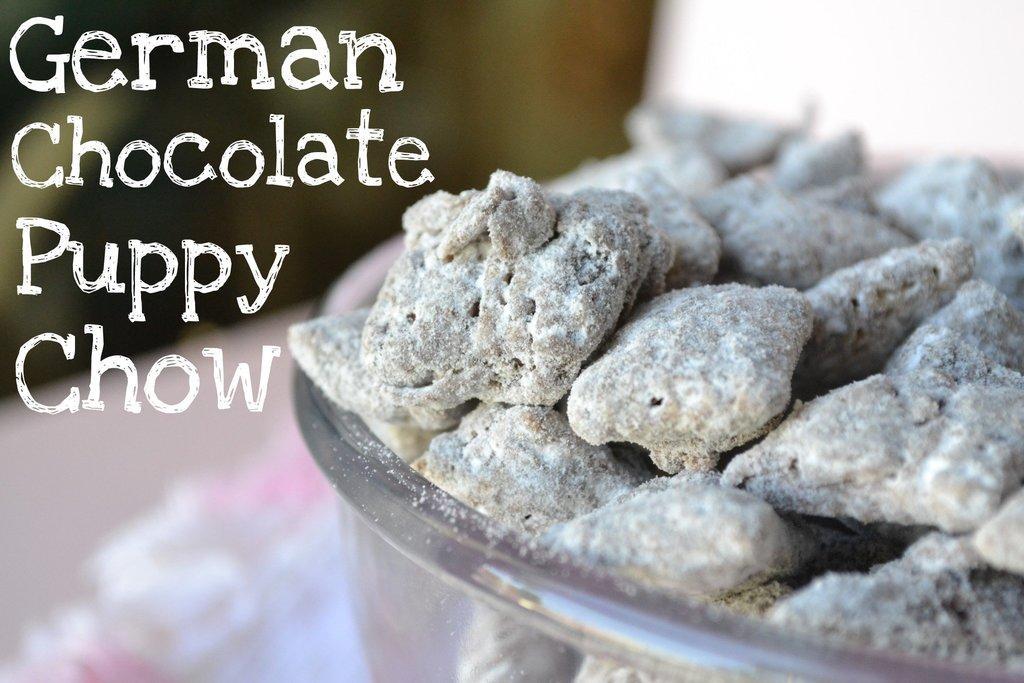Please provide a concise description of this image. In this image we can see there is a bowl full of german chocolate puppy chow. 